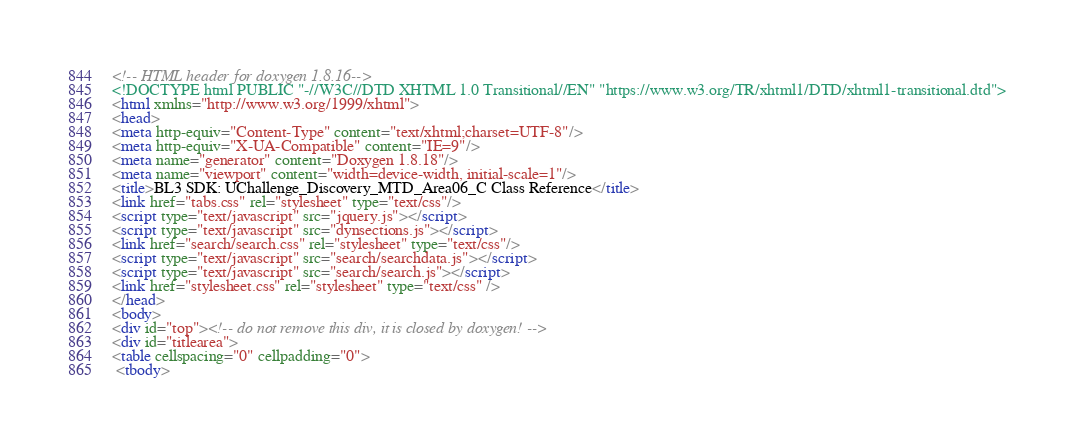Convert code to text. <code><loc_0><loc_0><loc_500><loc_500><_HTML_><!-- HTML header for doxygen 1.8.16-->
<!DOCTYPE html PUBLIC "-//W3C//DTD XHTML 1.0 Transitional//EN" "https://www.w3.org/TR/xhtml1/DTD/xhtml1-transitional.dtd">
<html xmlns="http://www.w3.org/1999/xhtml">
<head>
<meta http-equiv="Content-Type" content="text/xhtml;charset=UTF-8"/>
<meta http-equiv="X-UA-Compatible" content="IE=9"/>
<meta name="generator" content="Doxygen 1.8.18"/>
<meta name="viewport" content="width=device-width, initial-scale=1"/>
<title>BL3 SDK: UChallenge_Discovery_MTD_Area06_C Class Reference</title>
<link href="tabs.css" rel="stylesheet" type="text/css"/>
<script type="text/javascript" src="jquery.js"></script>
<script type="text/javascript" src="dynsections.js"></script>
<link href="search/search.css" rel="stylesheet" type="text/css"/>
<script type="text/javascript" src="search/searchdata.js"></script>
<script type="text/javascript" src="search/search.js"></script>
<link href="stylesheet.css" rel="stylesheet" type="text/css" />
</head>
<body>
<div id="top"><!-- do not remove this div, it is closed by doxygen! -->
<div id="titlearea">
<table cellspacing="0" cellpadding="0">
 <tbody></code> 